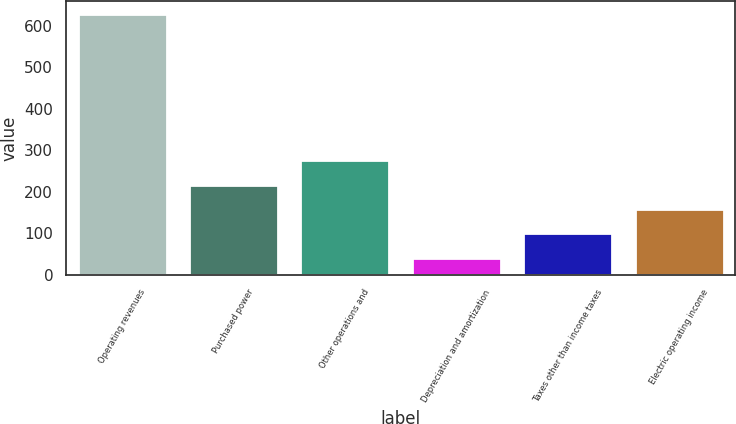Convert chart to OTSL. <chart><loc_0><loc_0><loc_500><loc_500><bar_chart><fcel>Operating revenues<fcel>Purchased power<fcel>Other operations and<fcel>Depreciation and amortization<fcel>Taxes other than income taxes<fcel>Electric operating income<nl><fcel>628<fcel>217.1<fcel>275.8<fcel>41<fcel>99.7<fcel>158.4<nl></chart> 